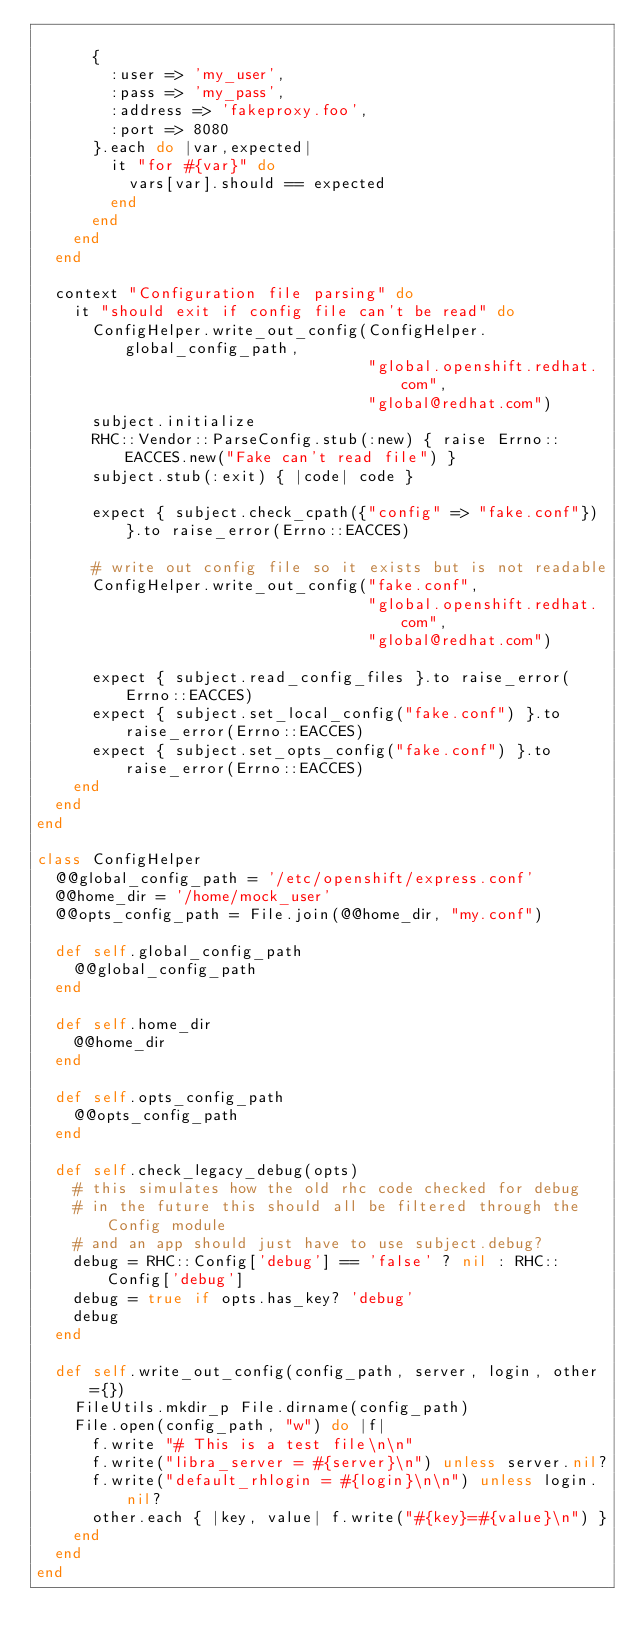<code> <loc_0><loc_0><loc_500><loc_500><_Ruby_>
      {
        :user => 'my_user',
        :pass => 'my_pass',
        :address => 'fakeproxy.foo',
        :port => 8080
      }.each do |var,expected|
        it "for #{var}" do
          vars[var].should == expected
        end
      end
    end
  end

  context "Configuration file parsing" do
    it "should exit if config file can't be read" do
      ConfigHelper.write_out_config(ConfigHelper.global_config_path,
                                    "global.openshift.redhat.com",
                                    "global@redhat.com")
      subject.initialize
      RHC::Vendor::ParseConfig.stub(:new) { raise Errno::EACCES.new("Fake can't read file") }
      subject.stub(:exit) { |code| code }

      expect { subject.check_cpath({"config" => "fake.conf"}) }.to raise_error(Errno::EACCES)

      # write out config file so it exists but is not readable
      ConfigHelper.write_out_config("fake.conf",
                                    "global.openshift.redhat.com",
                                    "global@redhat.com")

      expect { subject.read_config_files }.to raise_error(Errno::EACCES)
      expect { subject.set_local_config("fake.conf") }.to raise_error(Errno::EACCES)
      expect { subject.set_opts_config("fake.conf") }.to raise_error(Errno::EACCES)
    end
  end
end

class ConfigHelper
  @@global_config_path = '/etc/openshift/express.conf'
  @@home_dir = '/home/mock_user'
  @@opts_config_path = File.join(@@home_dir, "my.conf")

  def self.global_config_path
    @@global_config_path
  end

  def self.home_dir
    @@home_dir
  end

  def self.opts_config_path
    @@opts_config_path
  end

  def self.check_legacy_debug(opts)
    # this simulates how the old rhc code checked for debug
    # in the future this should all be filtered through the Config module
    # and an app should just have to use subject.debug?
    debug = RHC::Config['debug'] == 'false' ? nil : RHC::Config['debug']
    debug = true if opts.has_key? 'debug'
    debug
  end

  def self.write_out_config(config_path, server, login, other={})
    FileUtils.mkdir_p File.dirname(config_path)
    File.open(config_path, "w") do |f|
      f.write "# This is a test file\n\n"
      f.write("libra_server = #{server}\n") unless server.nil?
      f.write("default_rhlogin = #{login}\n\n") unless login.nil?
      other.each { |key, value| f.write("#{key}=#{value}\n") }
    end
  end
end
</code> 